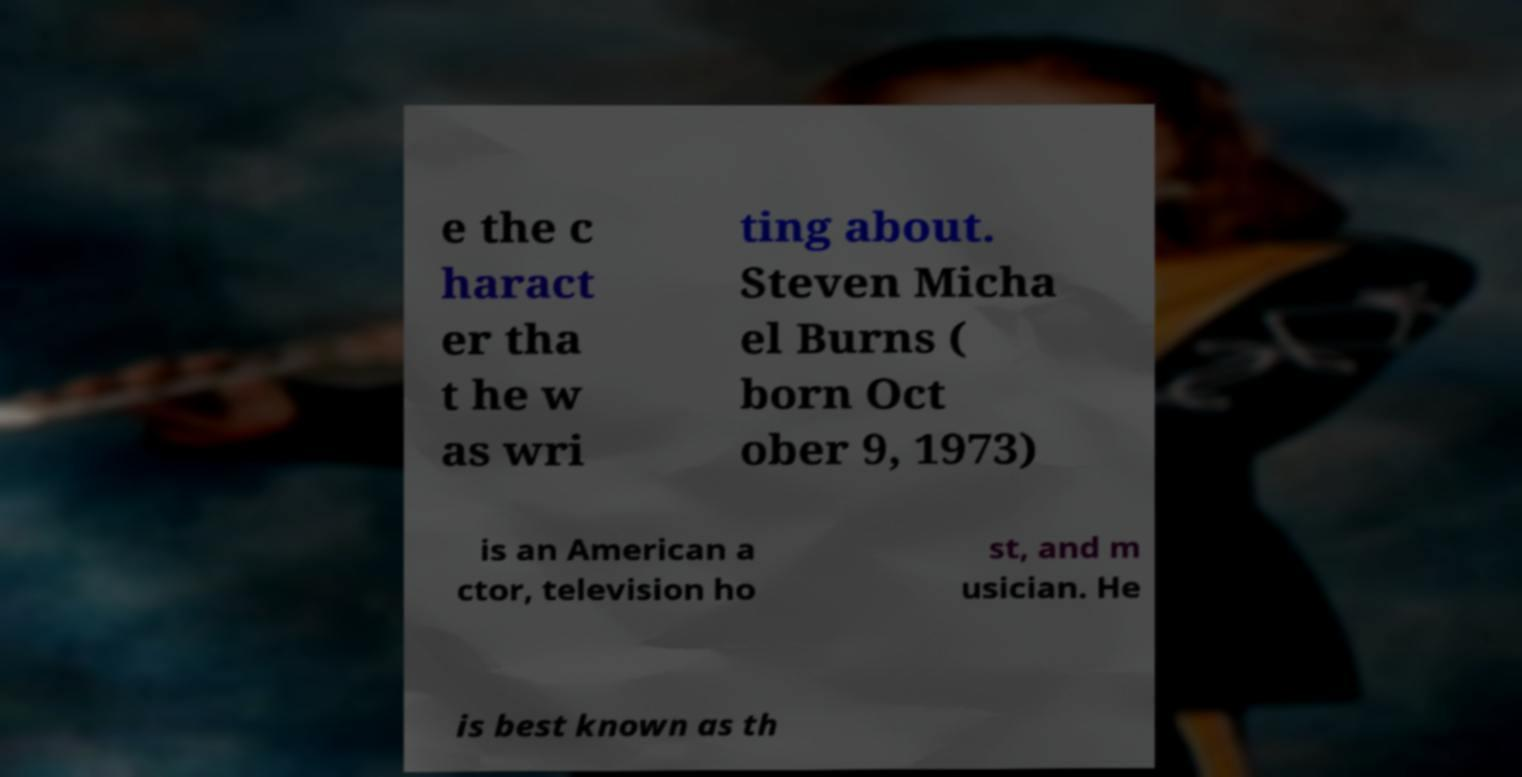Could you assist in decoding the text presented in this image and type it out clearly? e the c haract er tha t he w as wri ting about. Steven Micha el Burns ( born Oct ober 9, 1973) is an American a ctor, television ho st, and m usician. He is best known as th 